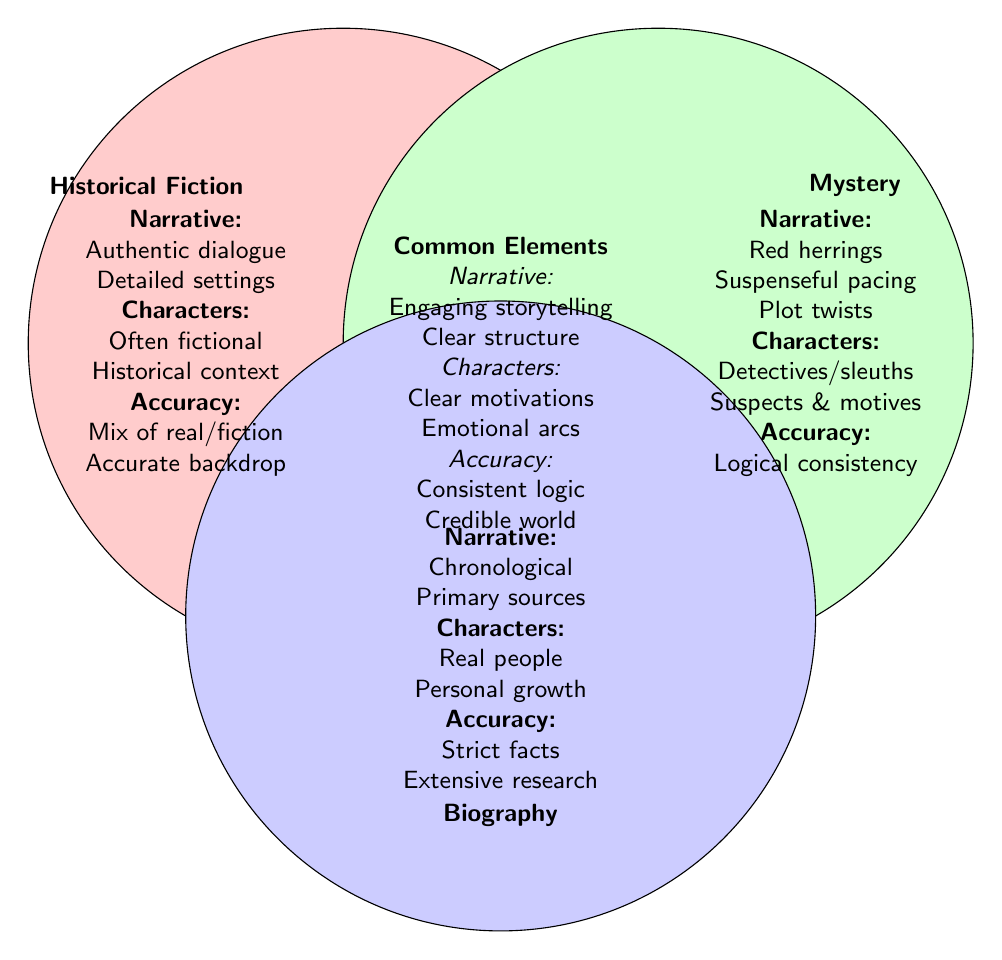What are the narrative techniques associated with historical fiction? The diagram lists three narrative techniques specific to historical fiction: authentic dialogue, detailed settings, and chronological structure. This information can be found in the section dedicated to historical fiction.
Answer: Authentic dialogue, detailed settings, chronological What is a common narrative element found in all three genres? The diagram mentions that engaging storytelling and clear structure are common narrative elements across historical fiction, mystery, and biography. This is noted where the overlapping area of the Venn diagram is labeled "Common Elements."
Answer: Engaging storytelling, clear structure Which genre emphasizes logical consistency in its accuracy aspect? Referring to the section dedicated to the mystery genre, it indicates that logical consistency is emphasized in its accuracy. This is visible as a key component listed under the accuracy section for mystery.
Answer: Logical consistency What type of characters are primarily depicted in biographies? The biography section specifies that the characters are "real people." This is straightforward as it directly states the nature of characters in that genre.
Answer: Real people How many narrative techniques are unique to the mystery genre? By examining the mystery section, there are three unique narrative techniques listed: red herrings, suspenseful pacing, and plot twists. This indicates that there are three distinct narrative features not shared with the other genres.
Answer: Three What type of accuracy is characteristic of historical fiction? The characteristics of historical fiction under the accuracy section describe it as a "mix of real/fiction" and "accurate backdrop." This shows that the accuracy is a blend of facts with fictional elements.
Answer: Mix of real/fiction What is one common characteristic related to character development across the genres? The Venn diagram's "Common Elements" section highlights that all genres feature clear motivations and emotional arcs in character development. This indicates a shared focus on how characters drive the narrative.
Answer: Clear motivations, emotional arcs Which narrative technique is unique to biography? The biography section mentions "primary sources" as a narrative technique that is not typically found in historical fiction or mystery, making this a unique aspect of the biography genre.
Answer: Primary sources 